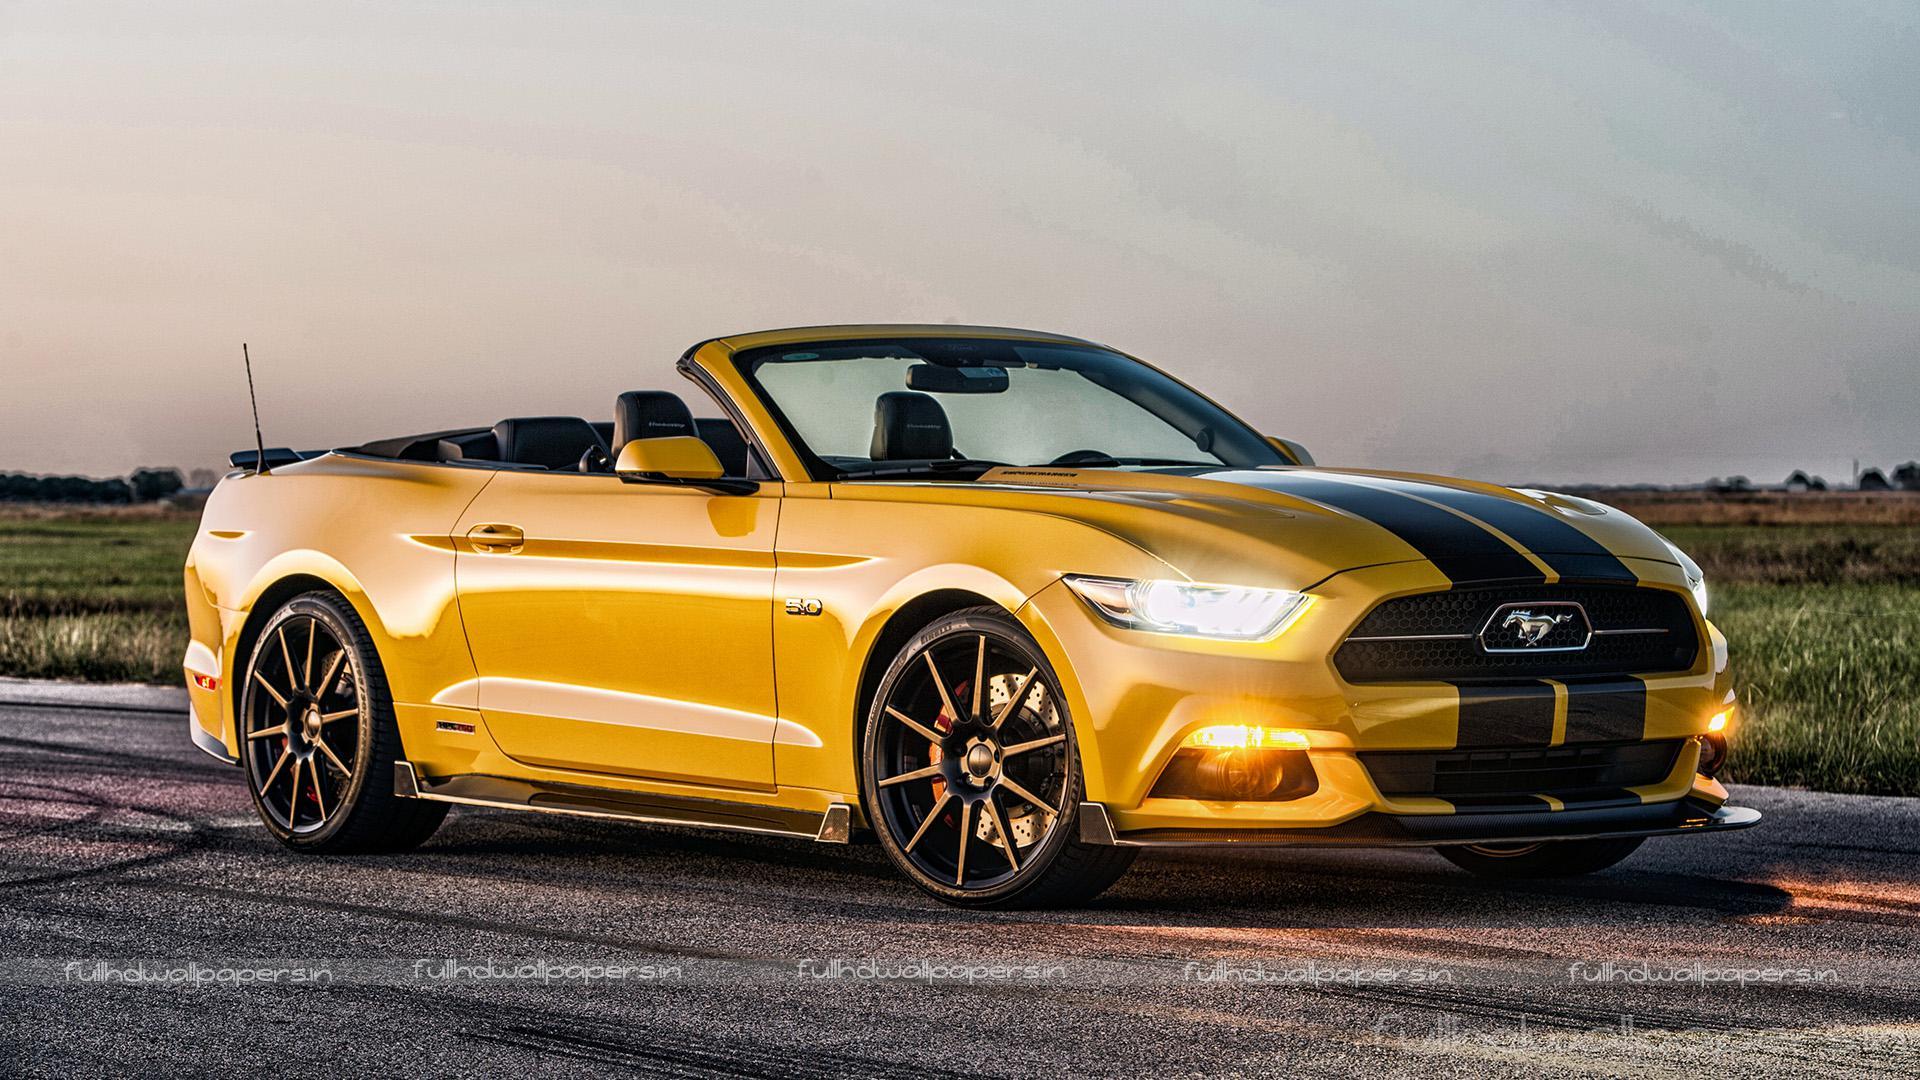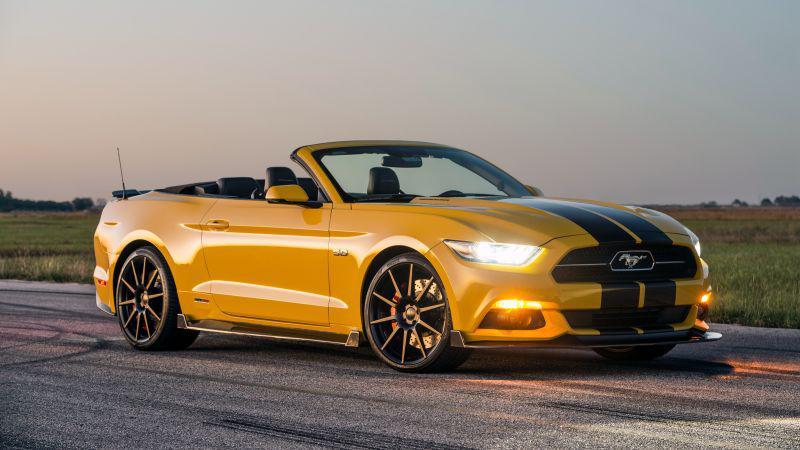The first image is the image on the left, the second image is the image on the right. Considering the images on both sides, is "Black stripes are visible on the hood of a yellow convertible aimed rightward." valid? Answer yes or no. Yes. The first image is the image on the left, the second image is the image on the right. Examine the images to the left and right. Is the description "There are two yellow convertibles facing to the right." accurate? Answer yes or no. Yes. 